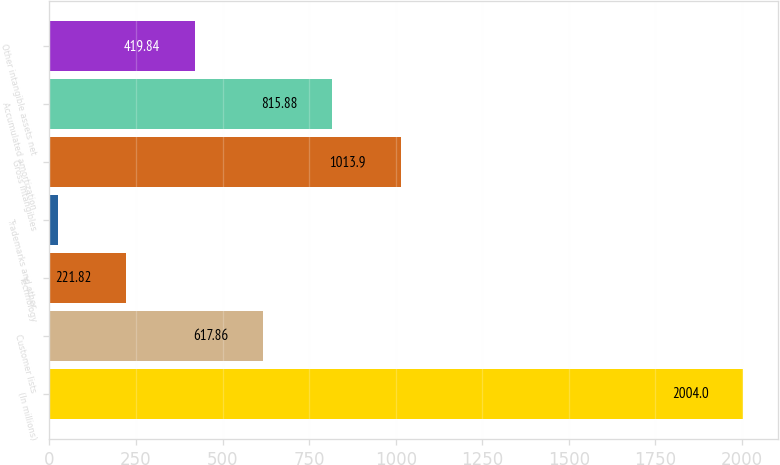<chart> <loc_0><loc_0><loc_500><loc_500><bar_chart><fcel>(In millions)<fcel>Customer lists<fcel>Technology<fcel>Trademarks and other<fcel>Gross intangibles<fcel>Accumulated amortization<fcel>Other intangible assets net<nl><fcel>2004<fcel>617.86<fcel>221.82<fcel>23.8<fcel>1013.9<fcel>815.88<fcel>419.84<nl></chart> 